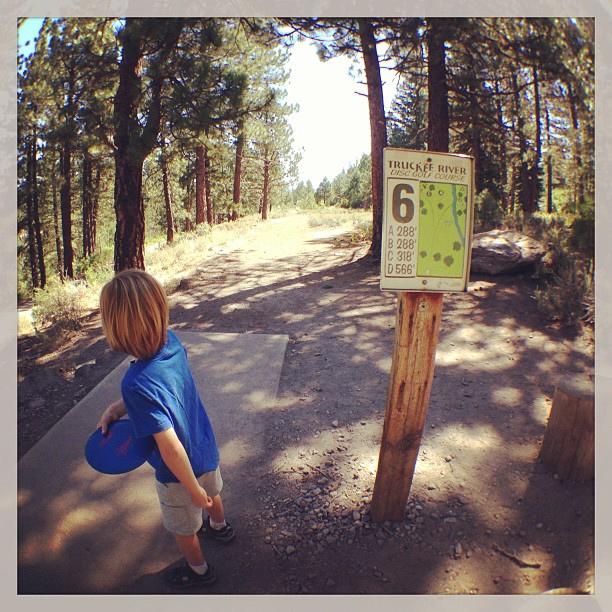What is the boy holding?
Keep it brief. Frisbee. What number is on the sign?
Give a very brief answer. 6. Which forest is this?
Concise answer only. Trucker river. 